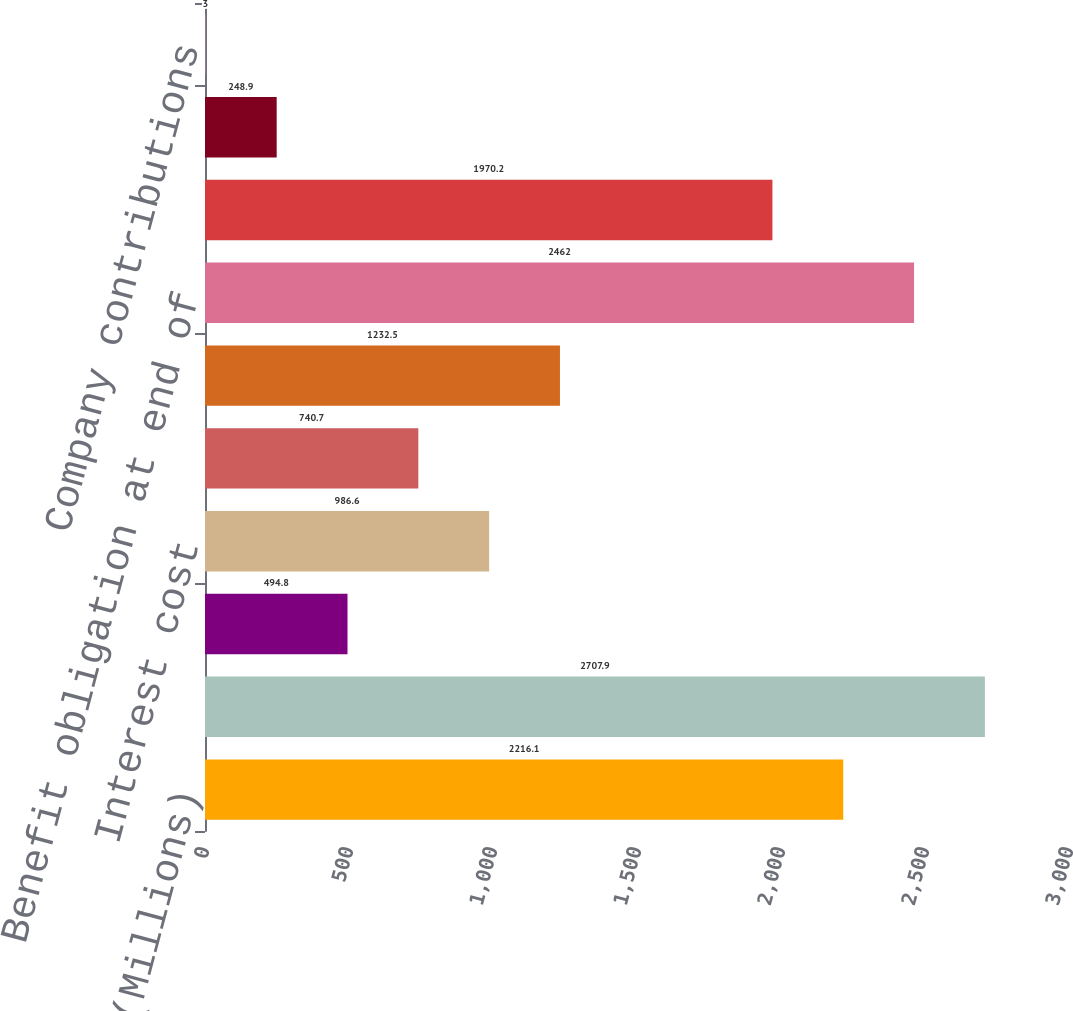Convert chart to OTSL. <chart><loc_0><loc_0><loc_500><loc_500><bar_chart><fcel>(Millions)<fcel>Benefit obligation at<fcel>Service cost<fcel>Interest cost<fcel>Actuarial (gain) loss<fcel>Benefit payments<fcel>Benefit obligation at end of<fcel>Fair value of plan assets at<fcel>Actual return on plan assets<fcel>Company contributions<nl><fcel>2216.1<fcel>2707.9<fcel>494.8<fcel>986.6<fcel>740.7<fcel>1232.5<fcel>2462<fcel>1970.2<fcel>248.9<fcel>3<nl></chart> 